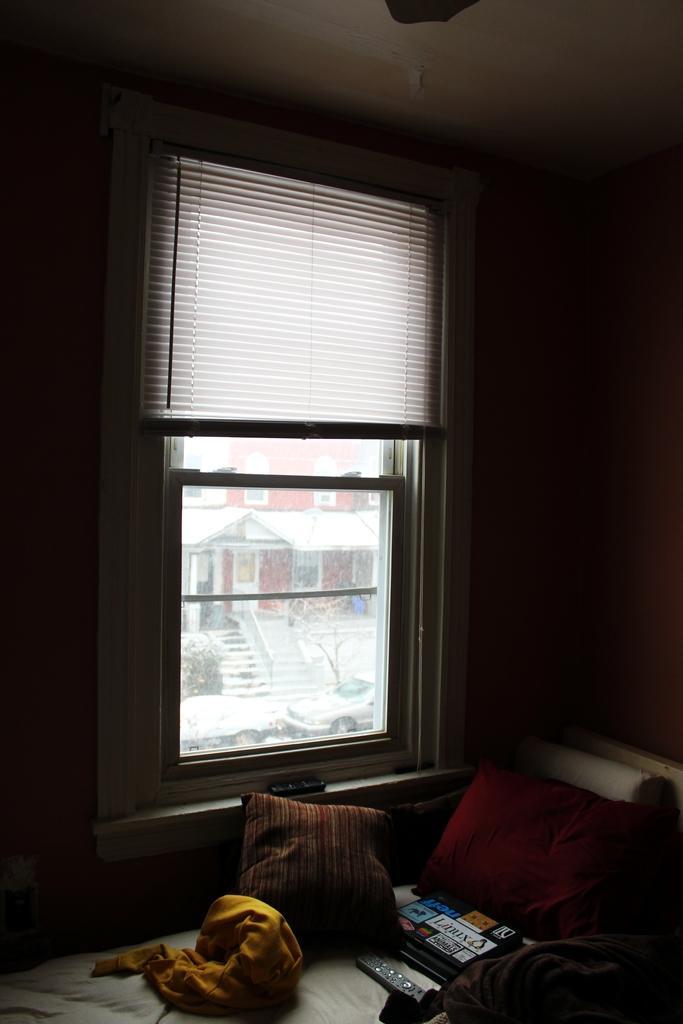Describe this image in one or two sentences. This image is taken indoors. In the background there is a wall with a window and there is a window blind. Through the window we can see there is a house and there is a ground covered with snow. There are two cars parked on the ground. At the bottom of the image there is a bed with a bedsheet, a few pillows, a blanket and a few things on it. 